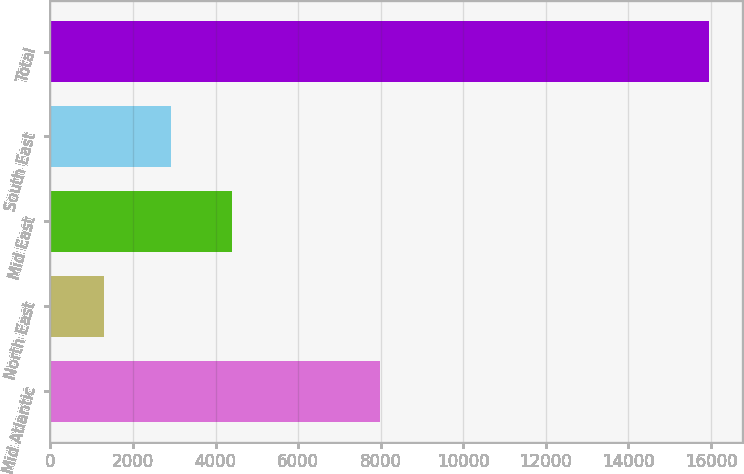<chart> <loc_0><loc_0><loc_500><loc_500><bar_chart><fcel>Mid Atlantic<fcel>North East<fcel>Mid East<fcel>South East<fcel>Total<nl><fcel>7971<fcel>1288<fcel>4397.3<fcel>2930<fcel>15961<nl></chart> 